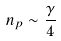<formula> <loc_0><loc_0><loc_500><loc_500>n _ { p } \sim \frac { \gamma } { 4 }</formula> 